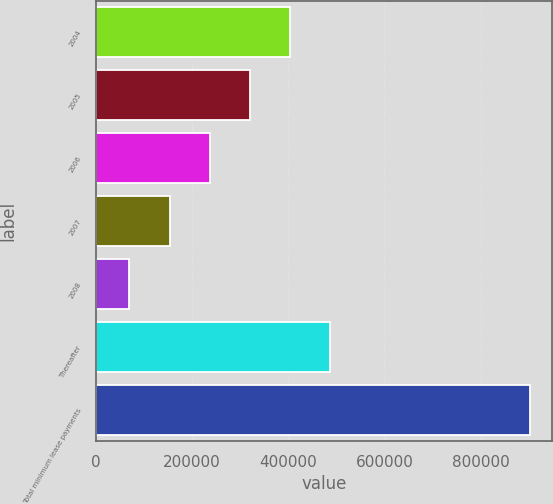Convert chart to OTSL. <chart><loc_0><loc_0><loc_500><loc_500><bar_chart><fcel>2004<fcel>2005<fcel>2006<fcel>2007<fcel>2008<fcel>Thereafter<fcel>Total minimum lease payments<nl><fcel>403368<fcel>320115<fcel>236862<fcel>153610<fcel>70357<fcel>486620<fcel>902884<nl></chart> 